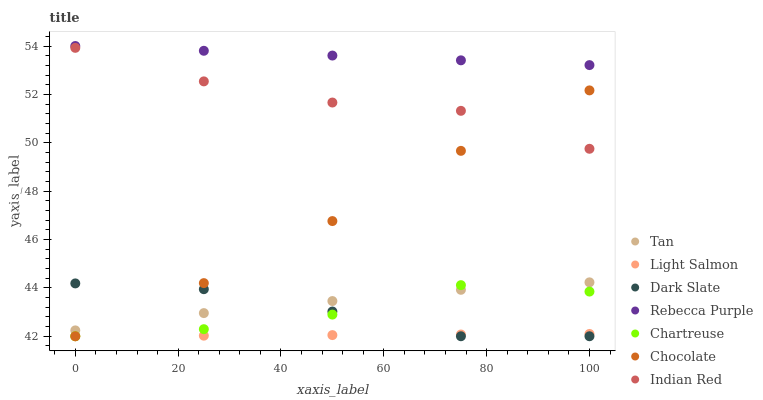Does Light Salmon have the minimum area under the curve?
Answer yes or no. Yes. Does Rebecca Purple have the maximum area under the curve?
Answer yes or no. Yes. Does Chocolate have the minimum area under the curve?
Answer yes or no. No. Does Chocolate have the maximum area under the curve?
Answer yes or no. No. Is Rebecca Purple the smoothest?
Answer yes or no. Yes. Is Chartreuse the roughest?
Answer yes or no. Yes. Is Chocolate the smoothest?
Answer yes or no. No. Is Chocolate the roughest?
Answer yes or no. No. Does Light Salmon have the lowest value?
Answer yes or no. Yes. Does Rebecca Purple have the lowest value?
Answer yes or no. No. Does Rebecca Purple have the highest value?
Answer yes or no. Yes. Does Chocolate have the highest value?
Answer yes or no. No. Is Chartreuse less than Rebecca Purple?
Answer yes or no. Yes. Is Indian Red greater than Dark Slate?
Answer yes or no. Yes. Does Chartreuse intersect Light Salmon?
Answer yes or no. Yes. Is Chartreuse less than Light Salmon?
Answer yes or no. No. Is Chartreuse greater than Light Salmon?
Answer yes or no. No. Does Chartreuse intersect Rebecca Purple?
Answer yes or no. No. 